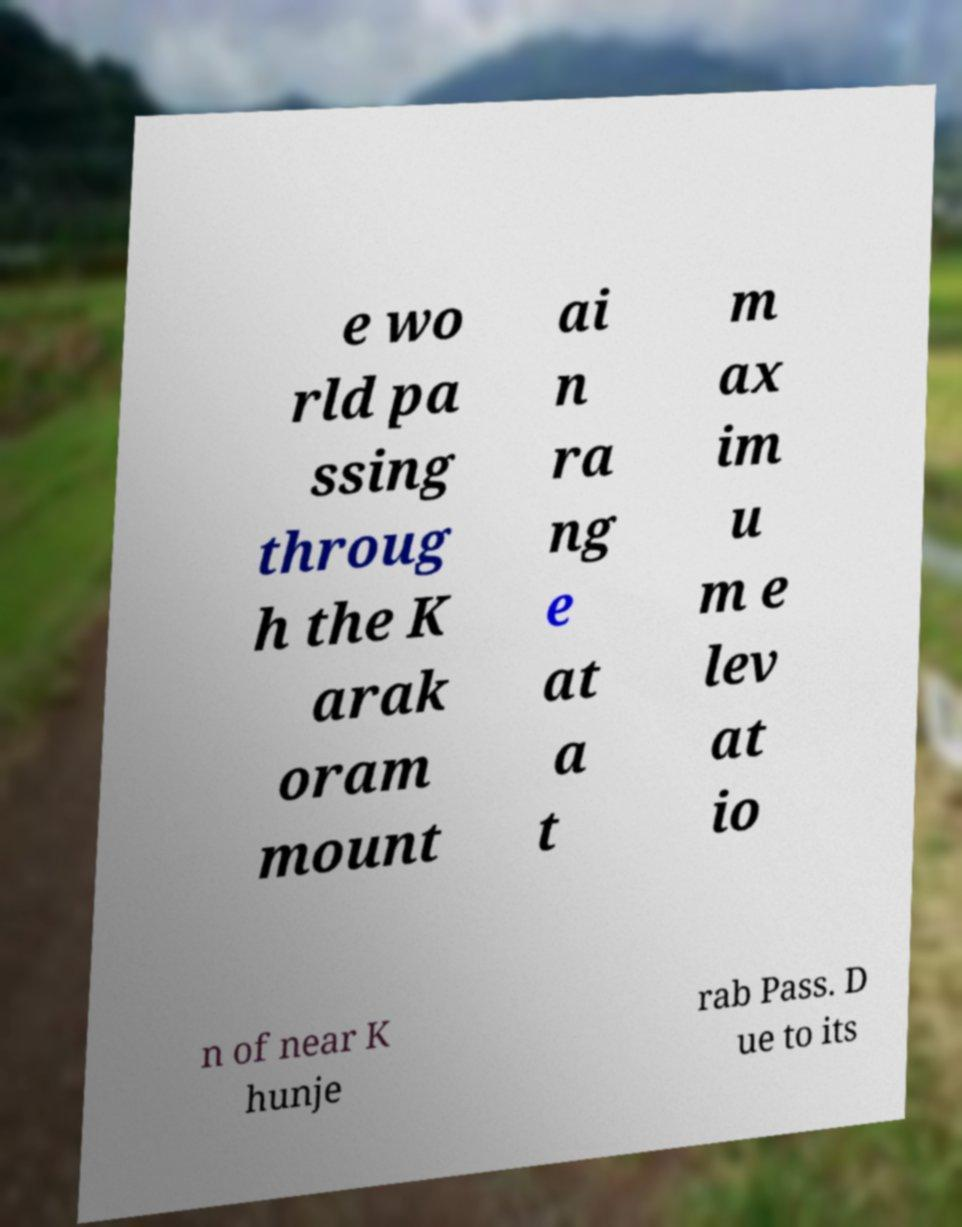Please identify and transcribe the text found in this image. e wo rld pa ssing throug h the K arak oram mount ai n ra ng e at a t m ax im u m e lev at io n of near K hunje rab Pass. D ue to its 